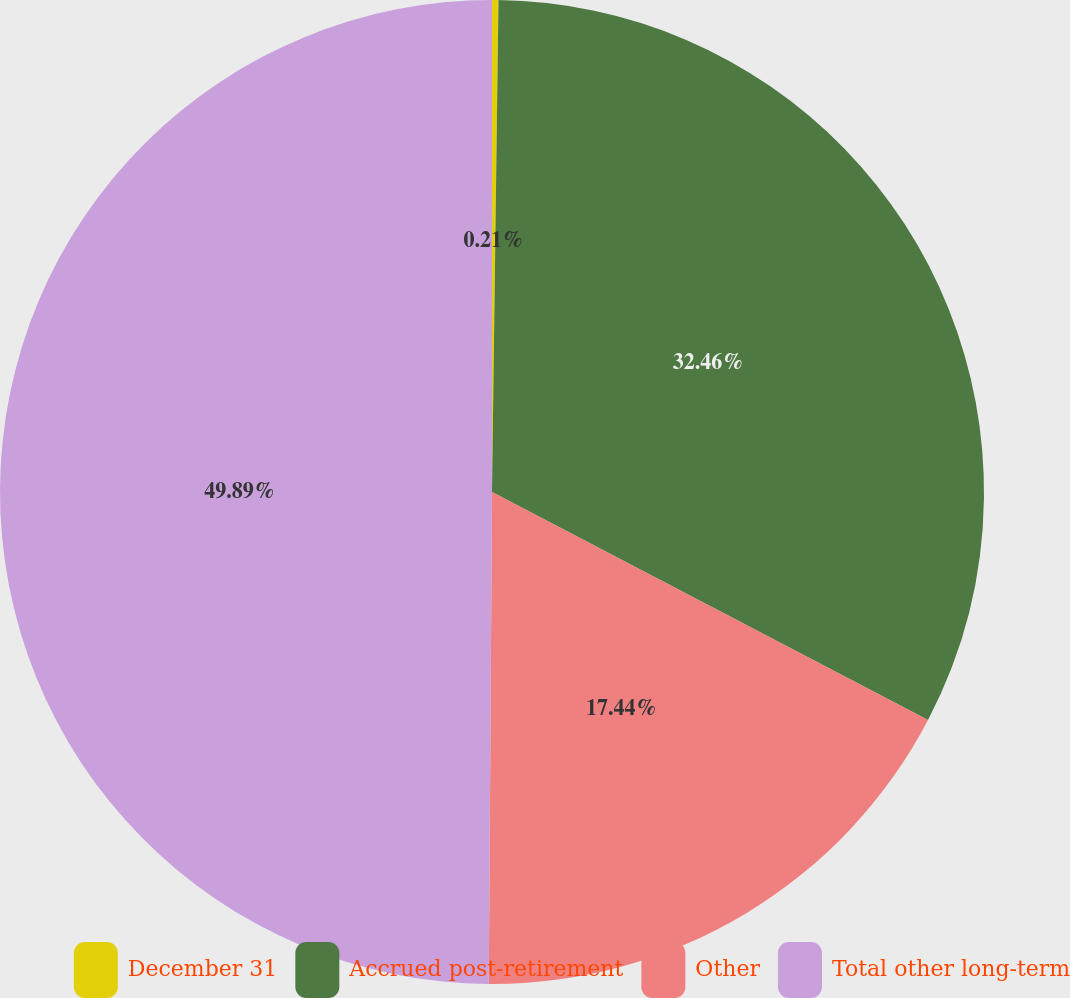Convert chart to OTSL. <chart><loc_0><loc_0><loc_500><loc_500><pie_chart><fcel>December 31<fcel>Accrued post-retirement<fcel>Other<fcel>Total other long-term<nl><fcel>0.21%<fcel>32.46%<fcel>17.44%<fcel>49.9%<nl></chart> 